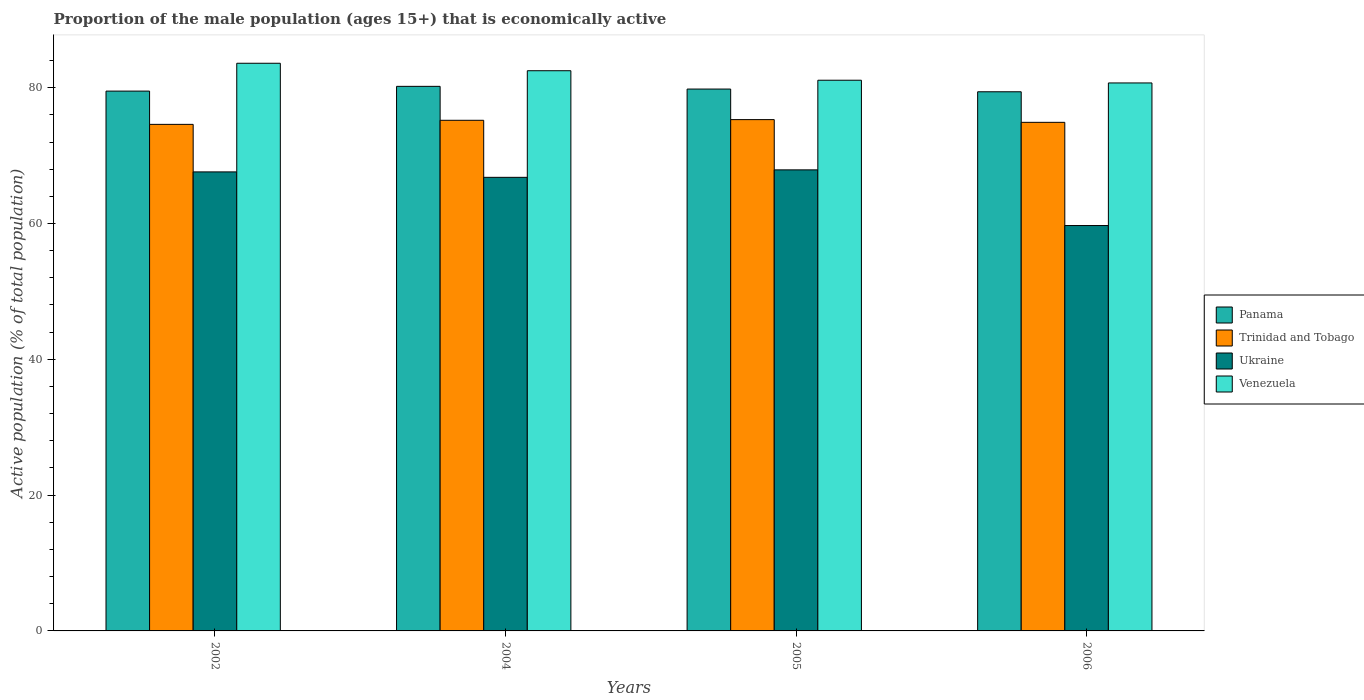How many groups of bars are there?
Keep it short and to the point. 4. How many bars are there on the 4th tick from the right?
Your answer should be compact. 4. What is the label of the 4th group of bars from the left?
Offer a terse response. 2006. In how many cases, is the number of bars for a given year not equal to the number of legend labels?
Provide a succinct answer. 0. What is the proportion of the male population that is economically active in Venezuela in 2002?
Ensure brevity in your answer.  83.6. Across all years, what is the maximum proportion of the male population that is economically active in Panama?
Offer a terse response. 80.2. Across all years, what is the minimum proportion of the male population that is economically active in Venezuela?
Your response must be concise. 80.7. In which year was the proportion of the male population that is economically active in Venezuela minimum?
Make the answer very short. 2006. What is the total proportion of the male population that is economically active in Panama in the graph?
Make the answer very short. 318.9. What is the difference between the proportion of the male population that is economically active in Trinidad and Tobago in 2002 and that in 2005?
Provide a succinct answer. -0.7. What is the difference between the proportion of the male population that is economically active in Ukraine in 2006 and the proportion of the male population that is economically active in Panama in 2004?
Keep it short and to the point. -20.5. What is the average proportion of the male population that is economically active in Ukraine per year?
Give a very brief answer. 65.5. In the year 2004, what is the difference between the proportion of the male population that is economically active in Ukraine and proportion of the male population that is economically active in Venezuela?
Give a very brief answer. -15.7. In how many years, is the proportion of the male population that is economically active in Ukraine greater than 72 %?
Your answer should be very brief. 0. What is the ratio of the proportion of the male population that is economically active in Panama in 2005 to that in 2006?
Ensure brevity in your answer.  1.01. Is the proportion of the male population that is economically active in Venezuela in 2002 less than that in 2006?
Provide a short and direct response. No. What is the difference between the highest and the second highest proportion of the male population that is economically active in Trinidad and Tobago?
Provide a short and direct response. 0.1. What is the difference between the highest and the lowest proportion of the male population that is economically active in Trinidad and Tobago?
Keep it short and to the point. 0.7. In how many years, is the proportion of the male population that is economically active in Panama greater than the average proportion of the male population that is economically active in Panama taken over all years?
Make the answer very short. 2. Is the sum of the proportion of the male population that is economically active in Venezuela in 2004 and 2006 greater than the maximum proportion of the male population that is economically active in Trinidad and Tobago across all years?
Your response must be concise. Yes. What does the 4th bar from the left in 2002 represents?
Give a very brief answer. Venezuela. What does the 1st bar from the right in 2005 represents?
Provide a short and direct response. Venezuela. Does the graph contain any zero values?
Ensure brevity in your answer.  No. Where does the legend appear in the graph?
Your response must be concise. Center right. What is the title of the graph?
Offer a very short reply. Proportion of the male population (ages 15+) that is economically active. Does "North America" appear as one of the legend labels in the graph?
Your answer should be compact. No. What is the label or title of the X-axis?
Make the answer very short. Years. What is the label or title of the Y-axis?
Your response must be concise. Active population (% of total population). What is the Active population (% of total population) of Panama in 2002?
Offer a very short reply. 79.5. What is the Active population (% of total population) of Trinidad and Tobago in 2002?
Provide a short and direct response. 74.6. What is the Active population (% of total population) of Ukraine in 2002?
Your answer should be compact. 67.6. What is the Active population (% of total population) of Venezuela in 2002?
Your answer should be very brief. 83.6. What is the Active population (% of total population) of Panama in 2004?
Make the answer very short. 80.2. What is the Active population (% of total population) in Trinidad and Tobago in 2004?
Make the answer very short. 75.2. What is the Active population (% of total population) of Ukraine in 2004?
Ensure brevity in your answer.  66.8. What is the Active population (% of total population) in Venezuela in 2004?
Your response must be concise. 82.5. What is the Active population (% of total population) of Panama in 2005?
Offer a terse response. 79.8. What is the Active population (% of total population) of Trinidad and Tobago in 2005?
Offer a very short reply. 75.3. What is the Active population (% of total population) in Ukraine in 2005?
Your answer should be very brief. 67.9. What is the Active population (% of total population) in Venezuela in 2005?
Ensure brevity in your answer.  81.1. What is the Active population (% of total population) in Panama in 2006?
Provide a succinct answer. 79.4. What is the Active population (% of total population) of Trinidad and Tobago in 2006?
Give a very brief answer. 74.9. What is the Active population (% of total population) of Ukraine in 2006?
Ensure brevity in your answer.  59.7. What is the Active population (% of total population) in Venezuela in 2006?
Keep it short and to the point. 80.7. Across all years, what is the maximum Active population (% of total population) in Panama?
Offer a terse response. 80.2. Across all years, what is the maximum Active population (% of total population) of Trinidad and Tobago?
Give a very brief answer. 75.3. Across all years, what is the maximum Active population (% of total population) in Ukraine?
Ensure brevity in your answer.  67.9. Across all years, what is the maximum Active population (% of total population) of Venezuela?
Your answer should be very brief. 83.6. Across all years, what is the minimum Active population (% of total population) in Panama?
Provide a succinct answer. 79.4. Across all years, what is the minimum Active population (% of total population) in Trinidad and Tobago?
Ensure brevity in your answer.  74.6. Across all years, what is the minimum Active population (% of total population) in Ukraine?
Offer a terse response. 59.7. Across all years, what is the minimum Active population (% of total population) in Venezuela?
Your response must be concise. 80.7. What is the total Active population (% of total population) in Panama in the graph?
Your response must be concise. 318.9. What is the total Active population (% of total population) of Trinidad and Tobago in the graph?
Ensure brevity in your answer.  300. What is the total Active population (% of total population) of Ukraine in the graph?
Your response must be concise. 262. What is the total Active population (% of total population) of Venezuela in the graph?
Give a very brief answer. 327.9. What is the difference between the Active population (% of total population) of Trinidad and Tobago in 2002 and that in 2006?
Offer a very short reply. -0.3. What is the difference between the Active population (% of total population) in Ukraine in 2002 and that in 2006?
Make the answer very short. 7.9. What is the difference between the Active population (% of total population) of Panama in 2004 and that in 2005?
Your response must be concise. 0.4. What is the difference between the Active population (% of total population) in Trinidad and Tobago in 2004 and that in 2005?
Your answer should be very brief. -0.1. What is the difference between the Active population (% of total population) of Venezuela in 2004 and that in 2005?
Your answer should be very brief. 1.4. What is the difference between the Active population (% of total population) in Panama in 2004 and that in 2006?
Your answer should be very brief. 0.8. What is the difference between the Active population (% of total population) in Trinidad and Tobago in 2004 and that in 2006?
Offer a terse response. 0.3. What is the difference between the Active population (% of total population) of Ukraine in 2004 and that in 2006?
Keep it short and to the point. 7.1. What is the difference between the Active population (% of total population) in Venezuela in 2004 and that in 2006?
Provide a succinct answer. 1.8. What is the difference between the Active population (% of total population) of Trinidad and Tobago in 2005 and that in 2006?
Ensure brevity in your answer.  0.4. What is the difference between the Active population (% of total population) in Venezuela in 2005 and that in 2006?
Offer a terse response. 0.4. What is the difference between the Active population (% of total population) of Panama in 2002 and the Active population (% of total population) of Ukraine in 2004?
Your answer should be compact. 12.7. What is the difference between the Active population (% of total population) in Trinidad and Tobago in 2002 and the Active population (% of total population) in Venezuela in 2004?
Your answer should be very brief. -7.9. What is the difference between the Active population (% of total population) of Ukraine in 2002 and the Active population (% of total population) of Venezuela in 2004?
Provide a succinct answer. -14.9. What is the difference between the Active population (% of total population) in Panama in 2002 and the Active population (% of total population) in Trinidad and Tobago in 2005?
Your answer should be very brief. 4.2. What is the difference between the Active population (% of total population) in Panama in 2002 and the Active population (% of total population) in Ukraine in 2005?
Give a very brief answer. 11.6. What is the difference between the Active population (% of total population) of Trinidad and Tobago in 2002 and the Active population (% of total population) of Ukraine in 2005?
Offer a very short reply. 6.7. What is the difference between the Active population (% of total population) in Trinidad and Tobago in 2002 and the Active population (% of total population) in Venezuela in 2005?
Offer a very short reply. -6.5. What is the difference between the Active population (% of total population) in Panama in 2002 and the Active population (% of total population) in Ukraine in 2006?
Keep it short and to the point. 19.8. What is the difference between the Active population (% of total population) in Trinidad and Tobago in 2002 and the Active population (% of total population) in Venezuela in 2006?
Make the answer very short. -6.1. What is the difference between the Active population (% of total population) in Ukraine in 2002 and the Active population (% of total population) in Venezuela in 2006?
Make the answer very short. -13.1. What is the difference between the Active population (% of total population) in Panama in 2004 and the Active population (% of total population) in Ukraine in 2005?
Your answer should be very brief. 12.3. What is the difference between the Active population (% of total population) of Panama in 2004 and the Active population (% of total population) of Venezuela in 2005?
Your answer should be compact. -0.9. What is the difference between the Active population (% of total population) in Trinidad and Tobago in 2004 and the Active population (% of total population) in Ukraine in 2005?
Give a very brief answer. 7.3. What is the difference between the Active population (% of total population) of Ukraine in 2004 and the Active population (% of total population) of Venezuela in 2005?
Your answer should be compact. -14.3. What is the difference between the Active population (% of total population) of Panama in 2004 and the Active population (% of total population) of Ukraine in 2006?
Ensure brevity in your answer.  20.5. What is the difference between the Active population (% of total population) of Panama in 2004 and the Active population (% of total population) of Venezuela in 2006?
Your response must be concise. -0.5. What is the difference between the Active population (% of total population) in Trinidad and Tobago in 2004 and the Active population (% of total population) in Ukraine in 2006?
Give a very brief answer. 15.5. What is the difference between the Active population (% of total population) in Trinidad and Tobago in 2004 and the Active population (% of total population) in Venezuela in 2006?
Your answer should be very brief. -5.5. What is the difference between the Active population (% of total population) in Ukraine in 2004 and the Active population (% of total population) in Venezuela in 2006?
Make the answer very short. -13.9. What is the difference between the Active population (% of total population) in Panama in 2005 and the Active population (% of total population) in Trinidad and Tobago in 2006?
Your answer should be compact. 4.9. What is the difference between the Active population (% of total population) of Panama in 2005 and the Active population (% of total population) of Ukraine in 2006?
Your response must be concise. 20.1. What is the difference between the Active population (% of total population) in Trinidad and Tobago in 2005 and the Active population (% of total population) in Venezuela in 2006?
Your response must be concise. -5.4. What is the average Active population (% of total population) of Panama per year?
Offer a very short reply. 79.72. What is the average Active population (% of total population) in Trinidad and Tobago per year?
Provide a succinct answer. 75. What is the average Active population (% of total population) of Ukraine per year?
Provide a succinct answer. 65.5. What is the average Active population (% of total population) of Venezuela per year?
Your answer should be compact. 81.97. In the year 2002, what is the difference between the Active population (% of total population) of Panama and Active population (% of total population) of Ukraine?
Give a very brief answer. 11.9. In the year 2002, what is the difference between the Active population (% of total population) of Panama and Active population (% of total population) of Venezuela?
Keep it short and to the point. -4.1. In the year 2002, what is the difference between the Active population (% of total population) of Trinidad and Tobago and Active population (% of total population) of Ukraine?
Make the answer very short. 7. In the year 2002, what is the difference between the Active population (% of total population) in Trinidad and Tobago and Active population (% of total population) in Venezuela?
Your answer should be very brief. -9. In the year 2004, what is the difference between the Active population (% of total population) in Panama and Active population (% of total population) in Trinidad and Tobago?
Your response must be concise. 5. In the year 2004, what is the difference between the Active population (% of total population) of Panama and Active population (% of total population) of Ukraine?
Ensure brevity in your answer.  13.4. In the year 2004, what is the difference between the Active population (% of total population) in Panama and Active population (% of total population) in Venezuela?
Keep it short and to the point. -2.3. In the year 2004, what is the difference between the Active population (% of total population) of Trinidad and Tobago and Active population (% of total population) of Ukraine?
Make the answer very short. 8.4. In the year 2004, what is the difference between the Active population (% of total population) in Ukraine and Active population (% of total population) in Venezuela?
Give a very brief answer. -15.7. In the year 2005, what is the difference between the Active population (% of total population) in Trinidad and Tobago and Active population (% of total population) in Ukraine?
Provide a succinct answer. 7.4. In the year 2006, what is the difference between the Active population (% of total population) of Ukraine and Active population (% of total population) of Venezuela?
Make the answer very short. -21. What is the ratio of the Active population (% of total population) in Panama in 2002 to that in 2004?
Make the answer very short. 0.99. What is the ratio of the Active population (% of total population) in Trinidad and Tobago in 2002 to that in 2004?
Your answer should be compact. 0.99. What is the ratio of the Active population (% of total population) of Venezuela in 2002 to that in 2004?
Offer a very short reply. 1.01. What is the ratio of the Active population (% of total population) in Panama in 2002 to that in 2005?
Your response must be concise. 1. What is the ratio of the Active population (% of total population) in Trinidad and Tobago in 2002 to that in 2005?
Provide a succinct answer. 0.99. What is the ratio of the Active population (% of total population) in Venezuela in 2002 to that in 2005?
Your answer should be very brief. 1.03. What is the ratio of the Active population (% of total population) in Panama in 2002 to that in 2006?
Give a very brief answer. 1. What is the ratio of the Active population (% of total population) in Trinidad and Tobago in 2002 to that in 2006?
Provide a short and direct response. 1. What is the ratio of the Active population (% of total population) in Ukraine in 2002 to that in 2006?
Provide a short and direct response. 1.13. What is the ratio of the Active population (% of total population) of Venezuela in 2002 to that in 2006?
Provide a succinct answer. 1.04. What is the ratio of the Active population (% of total population) of Panama in 2004 to that in 2005?
Provide a short and direct response. 1. What is the ratio of the Active population (% of total population) in Ukraine in 2004 to that in 2005?
Your answer should be very brief. 0.98. What is the ratio of the Active population (% of total population) of Venezuela in 2004 to that in 2005?
Offer a very short reply. 1.02. What is the ratio of the Active population (% of total population) in Ukraine in 2004 to that in 2006?
Provide a short and direct response. 1.12. What is the ratio of the Active population (% of total population) in Venezuela in 2004 to that in 2006?
Keep it short and to the point. 1.02. What is the ratio of the Active population (% of total population) of Panama in 2005 to that in 2006?
Provide a short and direct response. 1. What is the ratio of the Active population (% of total population) of Ukraine in 2005 to that in 2006?
Ensure brevity in your answer.  1.14. What is the difference between the highest and the lowest Active population (% of total population) of Panama?
Your response must be concise. 0.8. What is the difference between the highest and the lowest Active population (% of total population) of Trinidad and Tobago?
Make the answer very short. 0.7. 